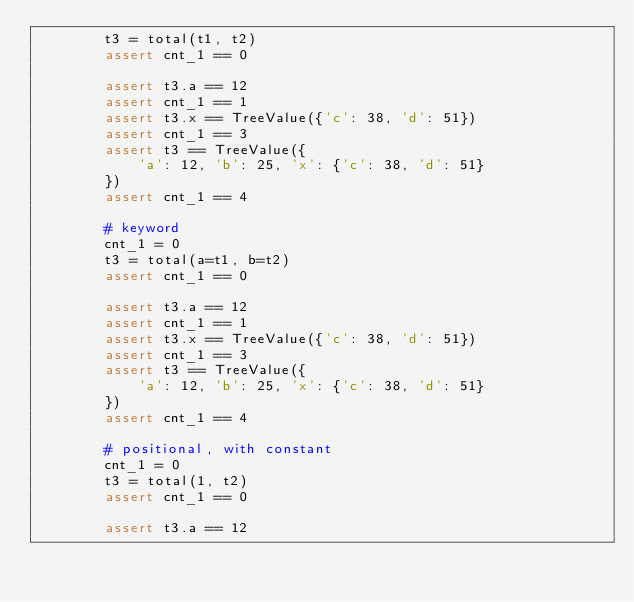Convert code to text. <code><loc_0><loc_0><loc_500><loc_500><_Python_>        t3 = total(t1, t2)
        assert cnt_1 == 0

        assert t3.a == 12
        assert cnt_1 == 1
        assert t3.x == TreeValue({'c': 38, 'd': 51})
        assert cnt_1 == 3
        assert t3 == TreeValue({
            'a': 12, 'b': 25, 'x': {'c': 38, 'd': 51}
        })
        assert cnt_1 == 4

        # keyword
        cnt_1 = 0
        t3 = total(a=t1, b=t2)
        assert cnt_1 == 0

        assert t3.a == 12
        assert cnt_1 == 1
        assert t3.x == TreeValue({'c': 38, 'd': 51})
        assert cnt_1 == 3
        assert t3 == TreeValue({
            'a': 12, 'b': 25, 'x': {'c': 38, 'd': 51}
        })
        assert cnt_1 == 4

        # positional, with constant
        cnt_1 = 0
        t3 = total(1, t2)
        assert cnt_1 == 0

        assert t3.a == 12</code> 